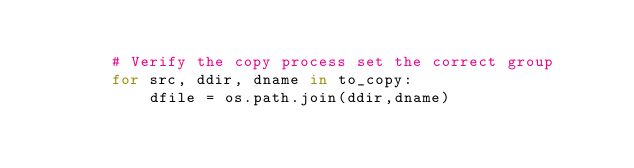<code> <loc_0><loc_0><loc_500><loc_500><_Python_>        
        # Verify the copy process set the correct group
        for src, ddir, dname in to_copy:
            dfile = os.path.join(ddir,dname)</code> 